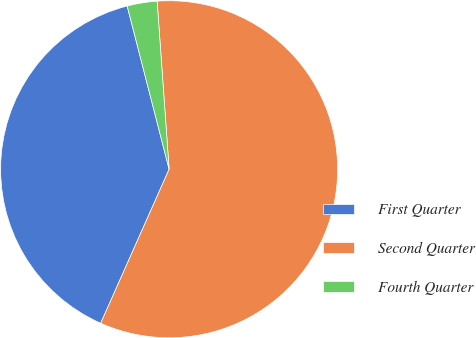<chart> <loc_0><loc_0><loc_500><loc_500><pie_chart><fcel>First Quarter<fcel>Second Quarter<fcel>Fourth Quarter<nl><fcel>39.34%<fcel>57.79%<fcel>2.87%<nl></chart> 